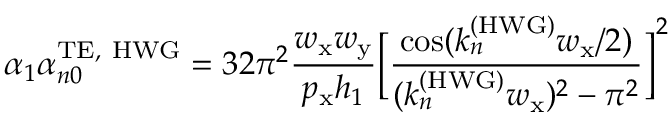<formula> <loc_0><loc_0><loc_500><loc_500>\alpha _ { 1 } \alpha _ { n 0 } ^ { T E , H W G } = 3 2 \pi ^ { 2 } \frac { w _ { x } w _ { y } } { p _ { x } h _ { 1 } } \left [ \frac { \cos ( k _ { n } ^ { ( H W G ) } w _ { x } / 2 ) } { ( k _ { n } ^ { ( H W G ) } w _ { x } ) ^ { 2 } - \pi ^ { 2 } } \right ] ^ { 2 }</formula> 